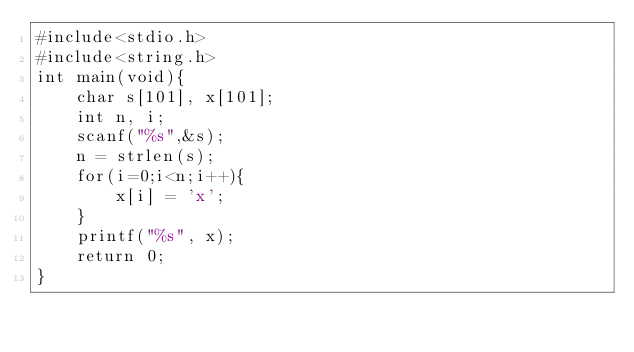<code> <loc_0><loc_0><loc_500><loc_500><_C_>#include<stdio.h>
#include<string.h>
int main(void){
    char s[101], x[101];
    int n, i;
    scanf("%s",&s);
    n = strlen(s);
    for(i=0;i<n;i++){
        x[i] = 'x';
    }
    printf("%s", x);
    return 0;
}</code> 